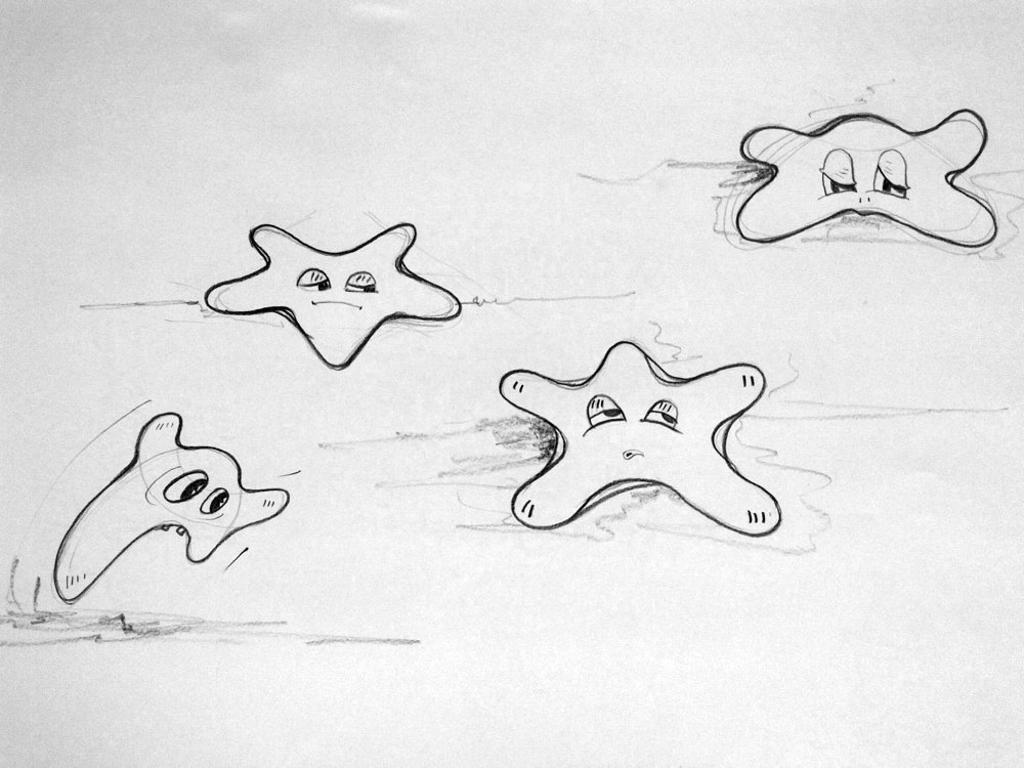Describe this image in one or two sentences. This image consists of a white color paper on which I can see few drawings of cartoons. 